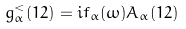Convert formula to latex. <formula><loc_0><loc_0><loc_500><loc_500>g _ { \alpha } ^ { < } ( 1 2 ) = i f _ { \alpha } ( \omega ) A _ { \alpha } ( 1 2 ) \\</formula> 